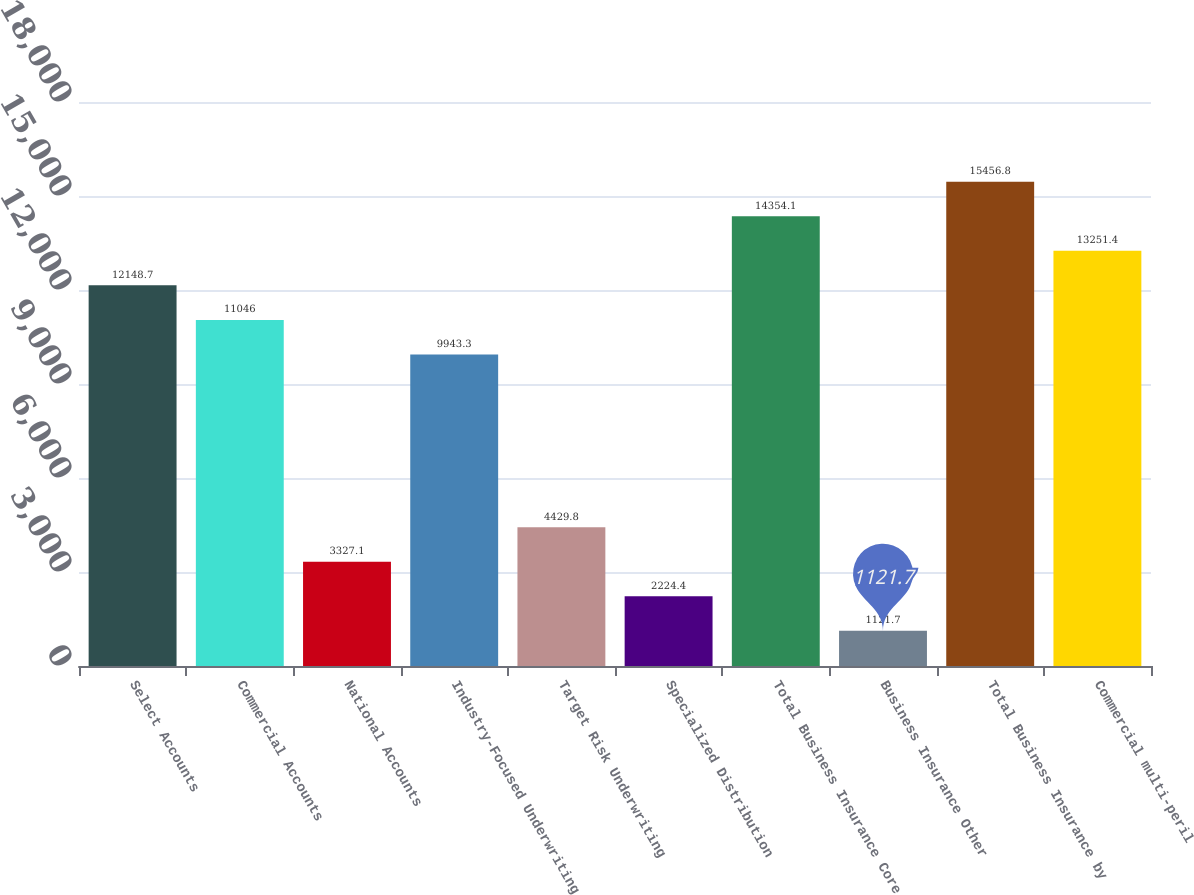<chart> <loc_0><loc_0><loc_500><loc_500><bar_chart><fcel>Select Accounts<fcel>Commercial Accounts<fcel>National Accounts<fcel>Industry-Focused Underwriting<fcel>Target Risk Underwriting<fcel>Specialized Distribution<fcel>Total Business Insurance Core<fcel>Business Insurance Other<fcel>Total Business Insurance by<fcel>Commercial multi-peril<nl><fcel>12148.7<fcel>11046<fcel>3327.1<fcel>9943.3<fcel>4429.8<fcel>2224.4<fcel>14354.1<fcel>1121.7<fcel>15456.8<fcel>13251.4<nl></chart> 